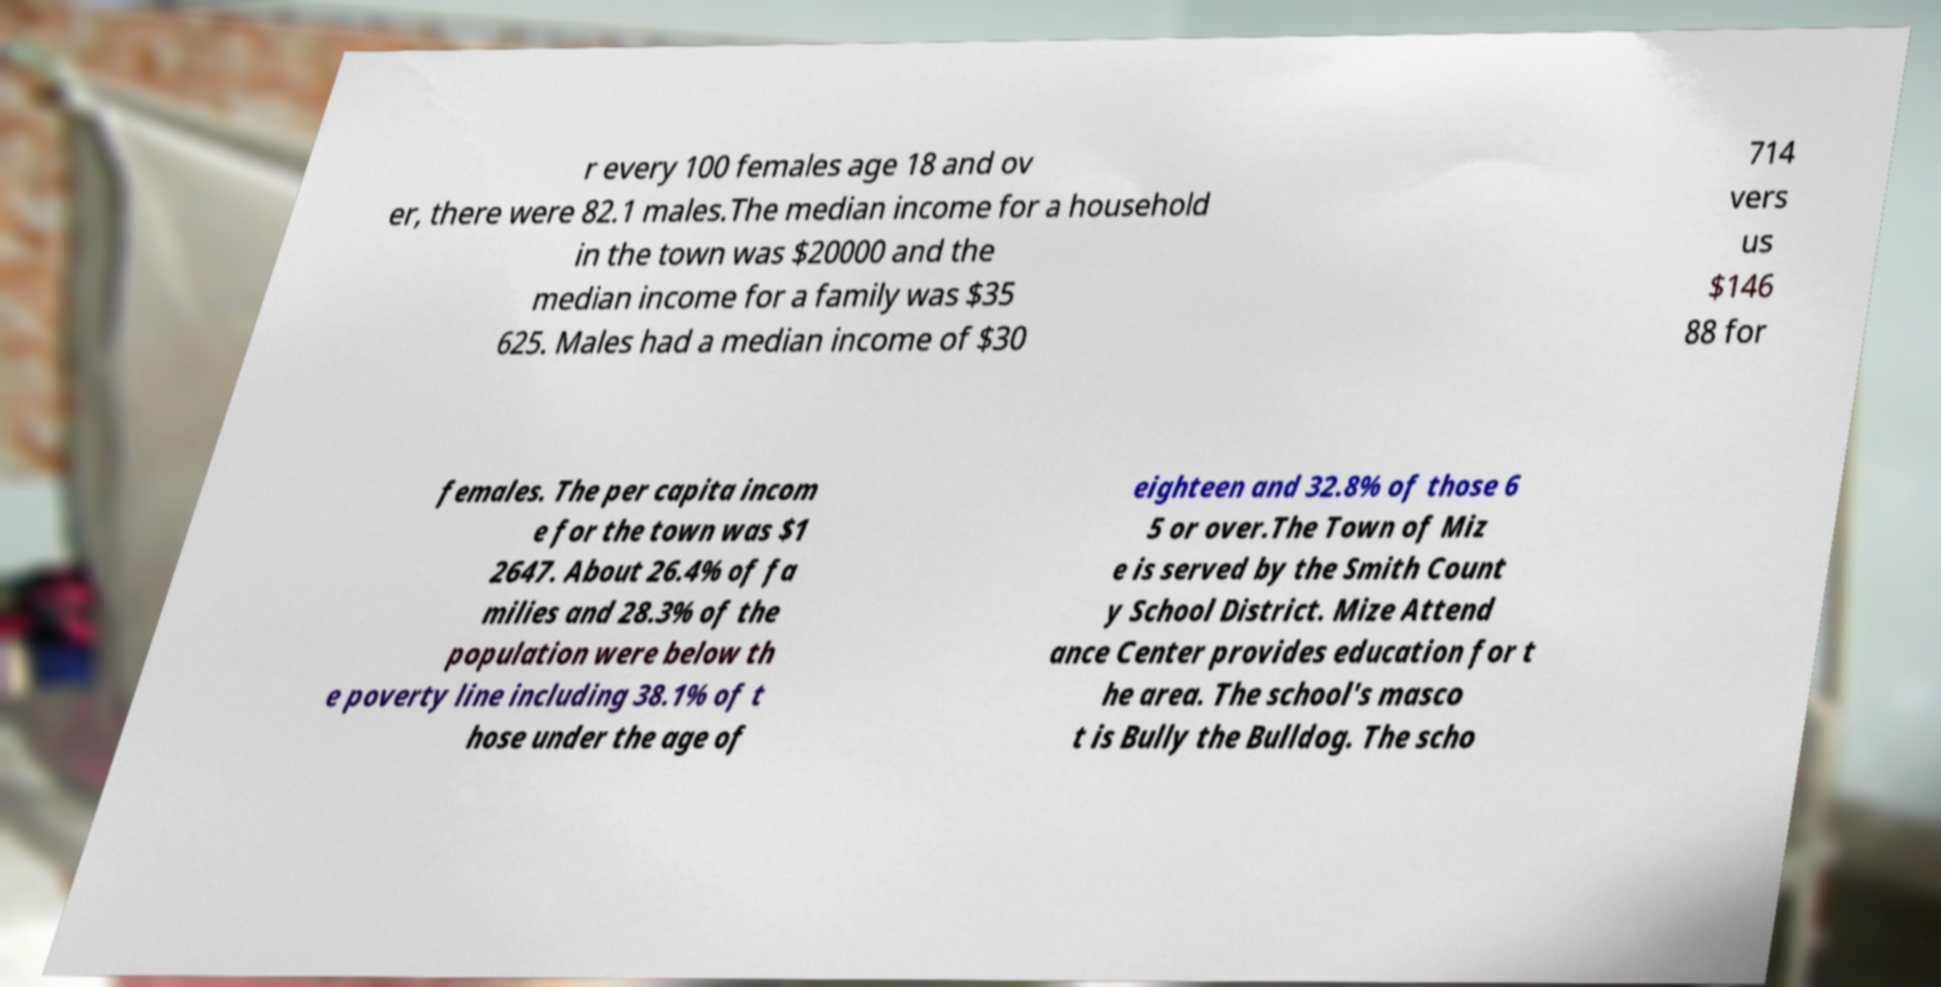Could you assist in decoding the text presented in this image and type it out clearly? r every 100 females age 18 and ov er, there were 82.1 males.The median income for a household in the town was $20000 and the median income for a family was $35 625. Males had a median income of $30 714 vers us $146 88 for females. The per capita incom e for the town was $1 2647. About 26.4% of fa milies and 28.3% of the population were below th e poverty line including 38.1% of t hose under the age of eighteen and 32.8% of those 6 5 or over.The Town of Miz e is served by the Smith Count y School District. Mize Attend ance Center provides education for t he area. The school's masco t is Bully the Bulldog. The scho 